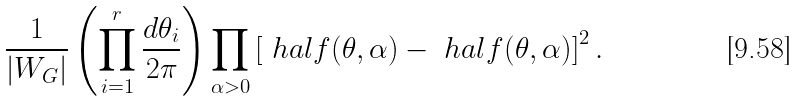<formula> <loc_0><loc_0><loc_500><loc_500>\frac { 1 } { | W _ { G } | } \left ( \prod _ { i = 1 } ^ { r } \frac { d \theta _ { i } } { 2 \pi } \right ) \prod _ { \alpha > 0 } \left [ \ h a l f ( \theta , \alpha ) - \ h a l f ( \theta , \alpha ) \right ] ^ { 2 } .</formula> 